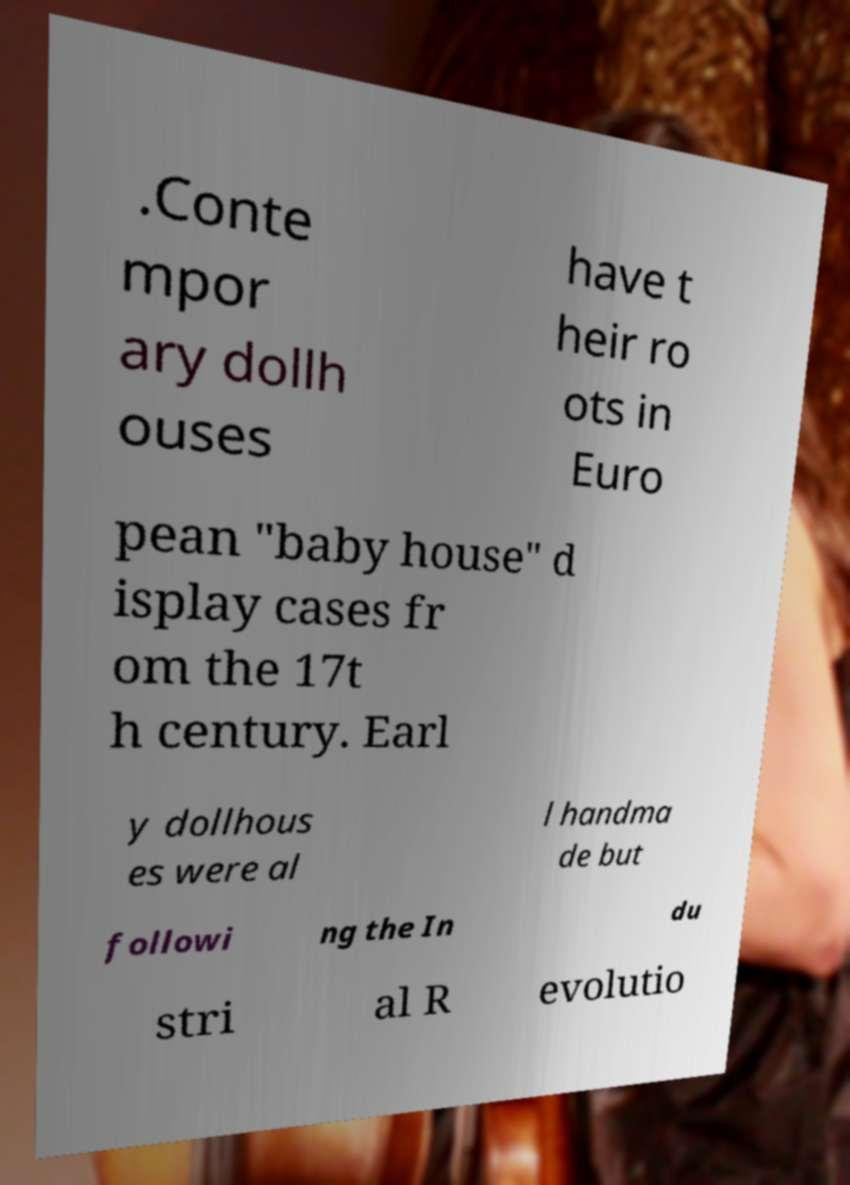Please read and relay the text visible in this image. What does it say? .Conte mpor ary dollh ouses have t heir ro ots in Euro pean "baby house" d isplay cases fr om the 17t h century. Earl y dollhous es were al l handma de but followi ng the In du stri al R evolutio 